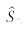Convert formula to latex. <formula><loc_0><loc_0><loc_500><loc_500>\hat { S } _ { n }</formula> 